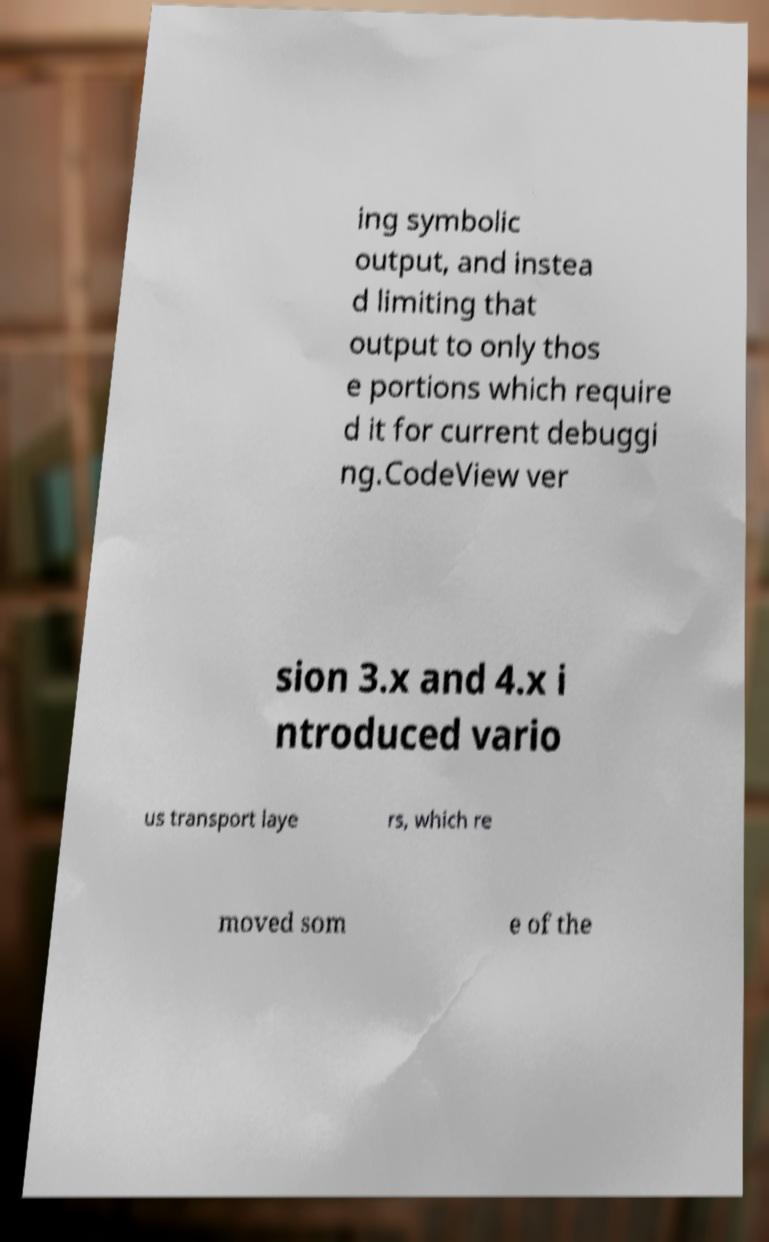Could you assist in decoding the text presented in this image and type it out clearly? ing symbolic output, and instea d limiting that output to only thos e portions which require d it for current debuggi ng.CodeView ver sion 3.x and 4.x i ntroduced vario us transport laye rs, which re moved som e of the 